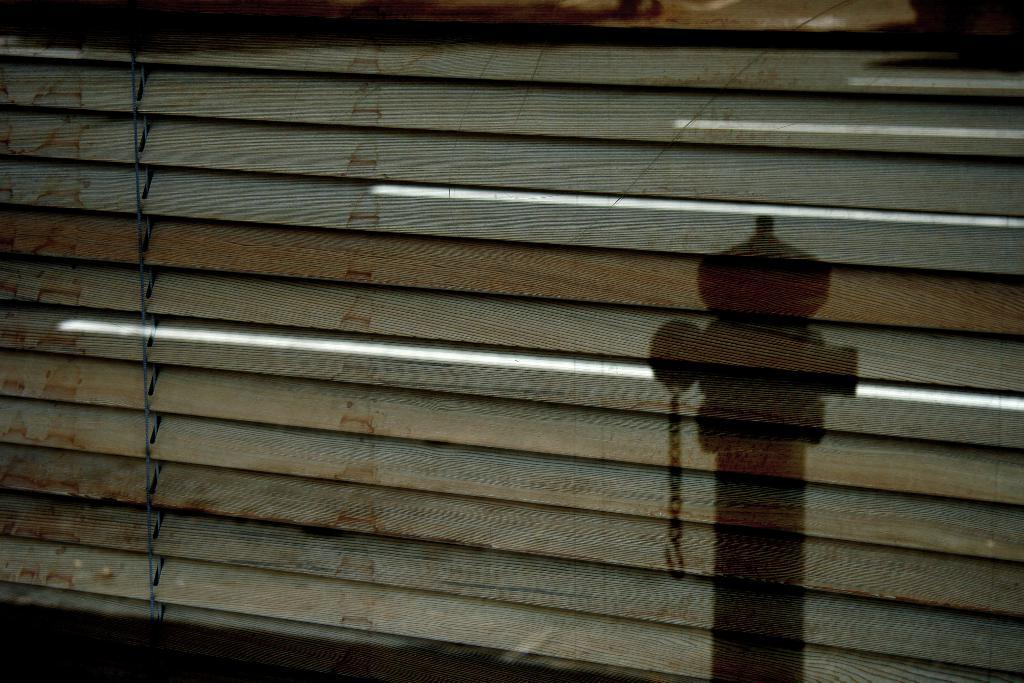What can be seen in the image that is not a solid object? There is a shadow in the image. What type of window covering is present in the image? There is a window curtain in the image. What type of ornament is hanging on the family's faces in the image? There is no family or ornaments present in the image; it only features a shadow and a window curtain. 